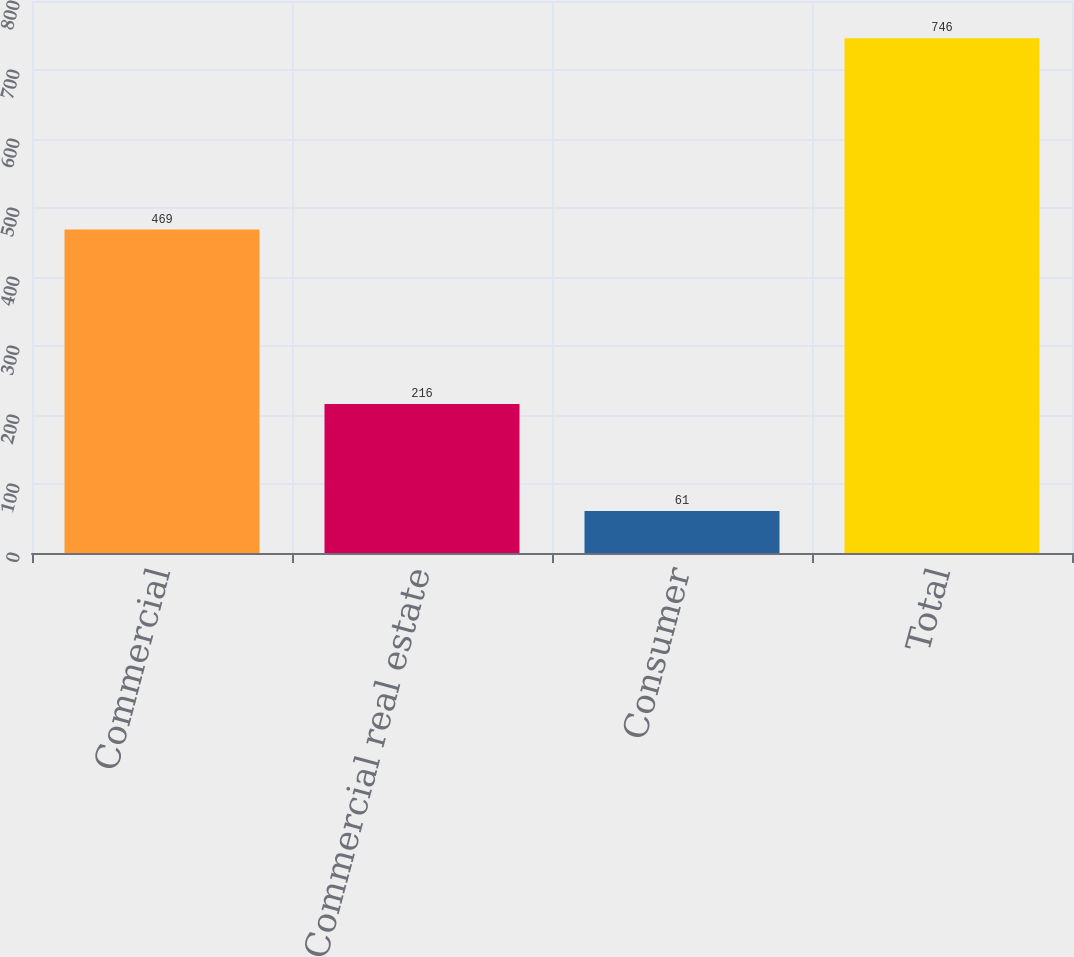Convert chart. <chart><loc_0><loc_0><loc_500><loc_500><bar_chart><fcel>Commercial<fcel>Commercial real estate<fcel>Consumer<fcel>Total<nl><fcel>469<fcel>216<fcel>61<fcel>746<nl></chart> 